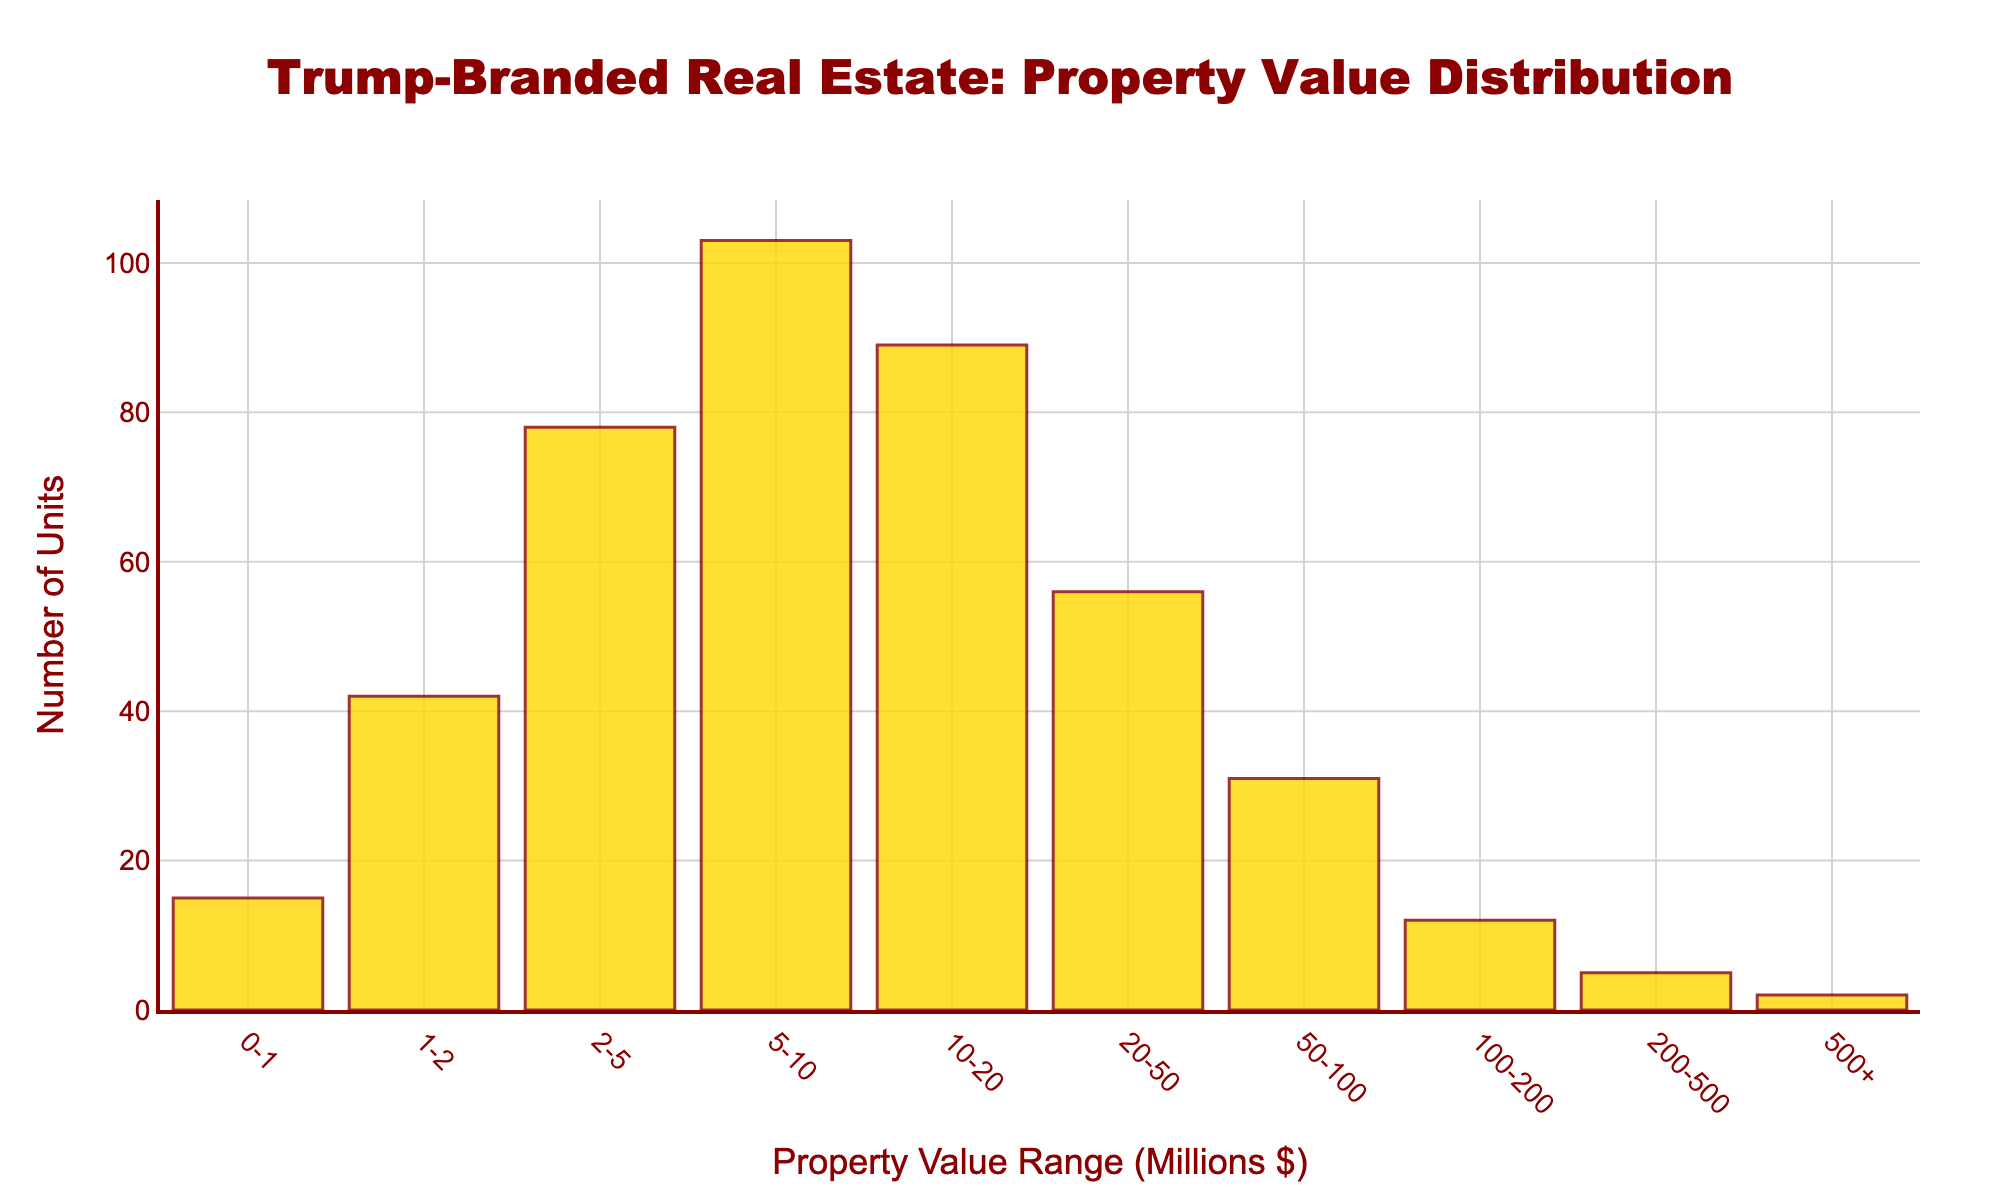How many property value ranges are represented in the histogram? Count the distinct property value ranges listed on the x-axis.
Answer: 10 What is the range with the highest number of units? Identify the bar with the highest y-value, which corresponds to the number of units. The tallest bar represents the highest number of units.
Answer: 5-10 How many units are there in the 20-50 million property value range? Look at the height of the bar corresponding to the 20-50 million range, which indicates the number of units.
Answer: 56 Which property value range has fewer than 10 units? Identify bars with a y-value (height) of fewer than 10 units. The corresponding x-axis value is the property value range.
Answer: 500+ What is the total number of units across all property value ranges? Sum the heights of all bars (add the number of units for each property value range).
Answer: 433 How do the number of units in the 100-200 million range compare to the 50-100 million range? Compare the heights of the bars for the 100-200 million range and the 50-100 million range. The y-values represent the number of units.
Answer: Less Between the ranges 0-1 million and 1-2 million, which has more units? Compare the heights of the bars for the 0-1 million and 1-2 million ranges. The taller bar indicates the range with more units.
Answer: 1-2 million What is the average number of units per property value range? Calculate the total number of units and divide it by the number of property value ranges.
Answer: 43.3 Is the distribution skewed towards higher or lower property values? Compare the height of bars at lower property value ranges to those at higher ranges. Determine the general trend to identify skewness.
Answer: Higher How many more units are there in the 5-10 million range compared to the 0-1 million range? Subtract the number of units in the 0-1 million range from the number of units in the 5-10 million range.
Answer: 88 